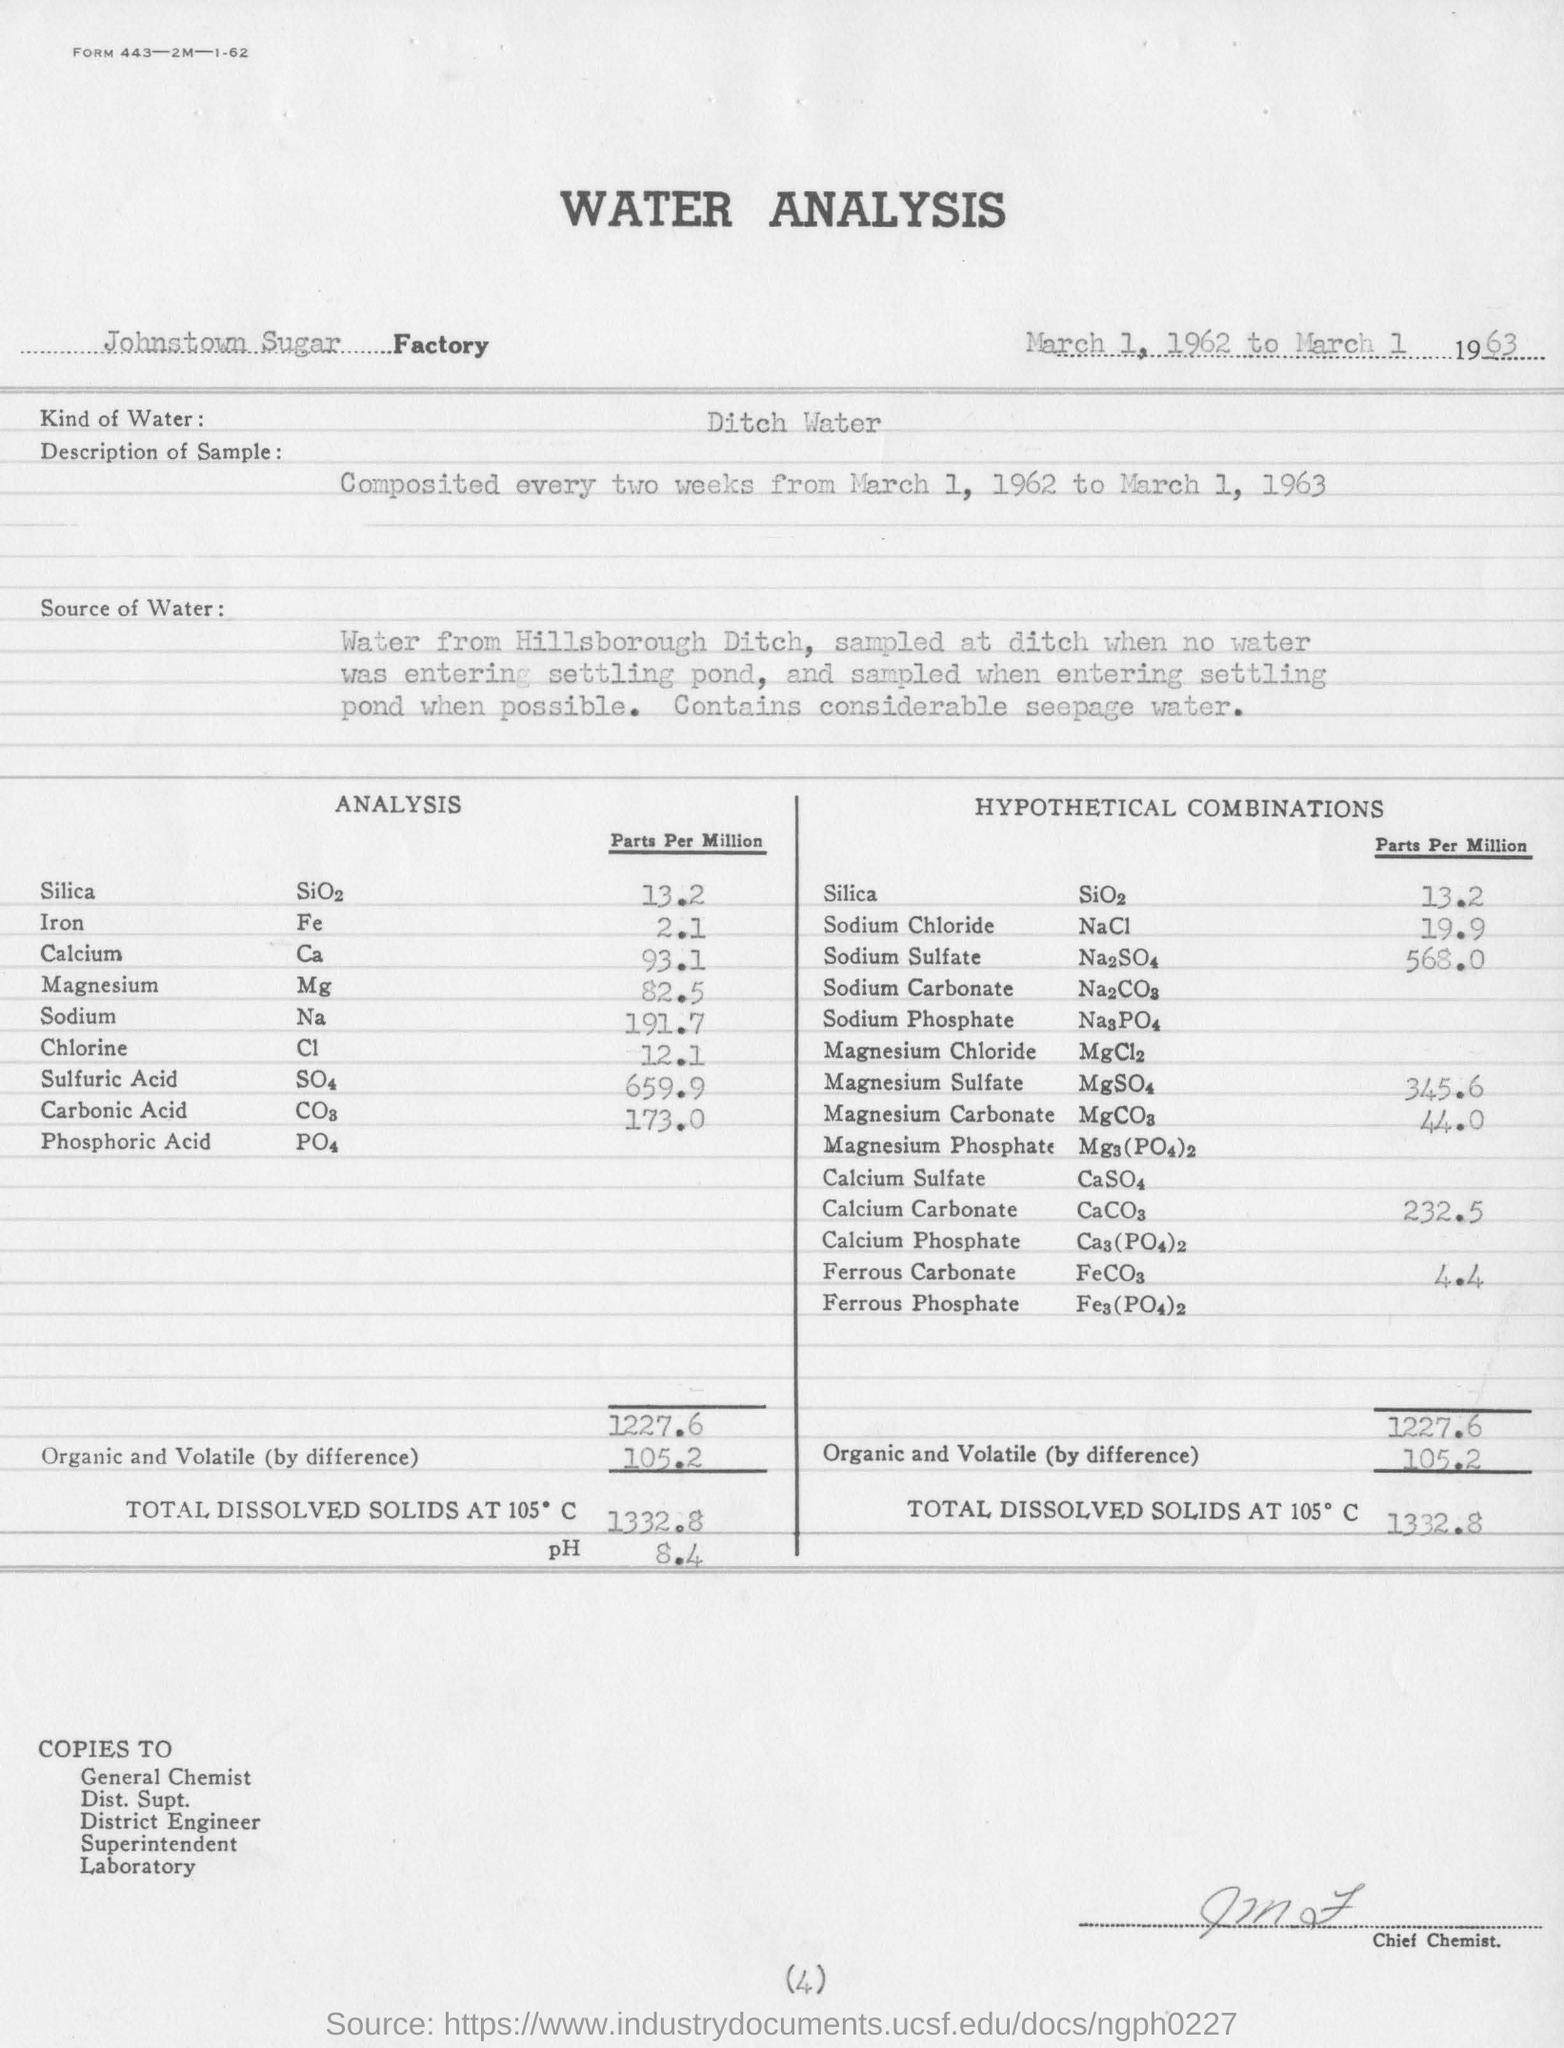How often is the sample collected?
Provide a succinct answer. Every two weeks. What is the pH Value?
Provide a succinct answer. 8.4. 